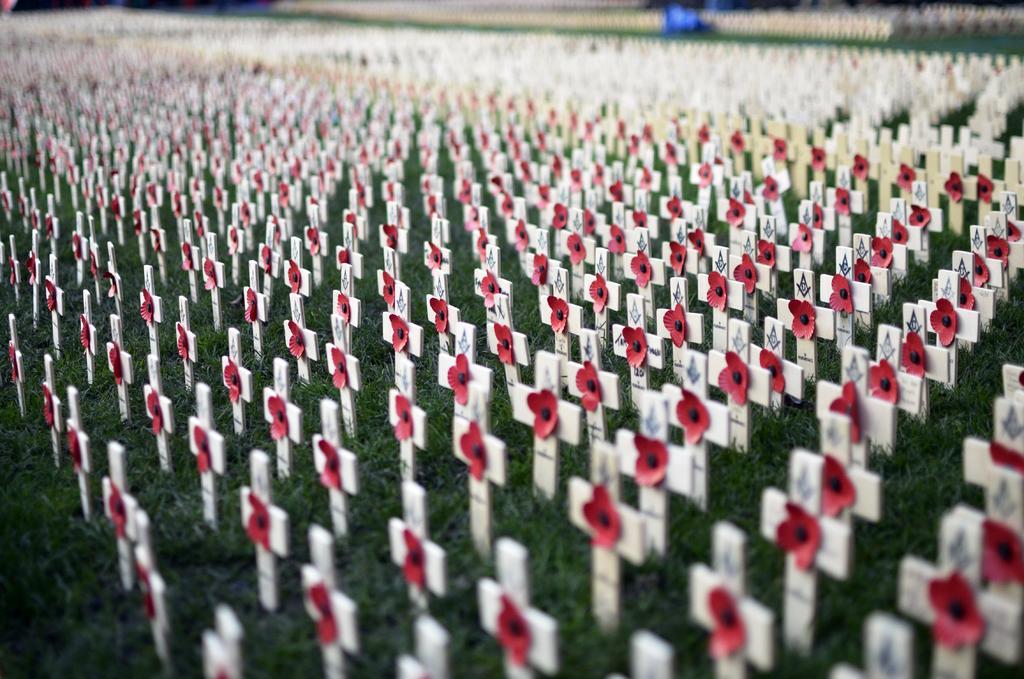In one or two sentences, can you explain what this image depicts? In this picture I can see so many holy cross symbols with flowers attached to it, on the grass, and there is blur background. 